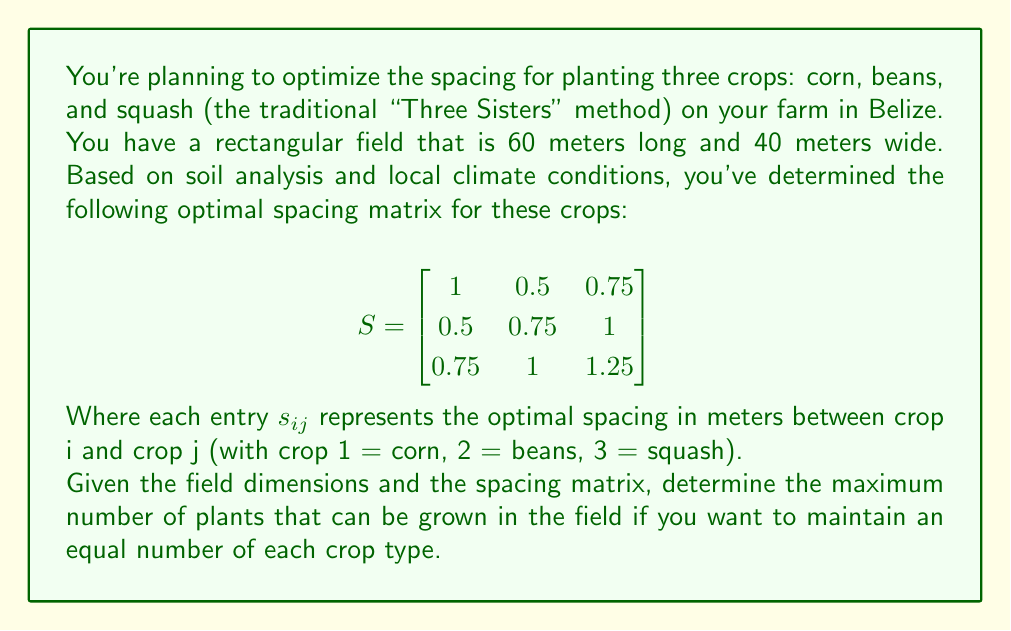Solve this math problem. Let's approach this step-by-step:

1) First, we need to determine the spacing between plants of the same type. This is given by the diagonal elements of the matrix S:
   - Corn: 1 meter
   - Beans: 0.75 meters
   - Squash: 1.25 meters

2) To maintain equal numbers of each crop, we'll use the largest spacing (1.25 meters for squash) as our grid size. This ensures we meet or exceed the spacing requirements for all crops.

3) Now, let's calculate how many plants we can fit in each dimension:
   - Length: $60 \text{ m} \div 1.25 \text{ m} = 48$ plants
   - Width: $40 \text{ m} \div 1.25 \text{ m} = 32$ plants

4) The total number of grid points is:
   $48 \times 32 = 1536$

5) Since we want an equal number of each crop, we need to divide this total by 3:
   $1536 \div 3 = 512$

Therefore, we can plant 512 of each crop type.

6) To verify:
   $512 \times 3 = 1536$, which matches our total grid points.

The arrangement could be visualized as a checkerboard pattern with each crop taking up one-third of the total spaces.
Answer: The maximum number of plants that can be grown while maintaining an equal number of each crop type is 512 corn plants, 512 bean plants, and 512 squash plants, for a total of 1,536 plants. 